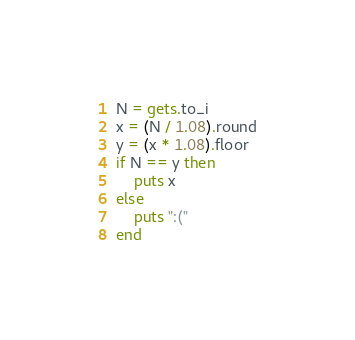<code> <loc_0><loc_0><loc_500><loc_500><_Ruby_>N = gets.to_i
x = (N / 1.08).round
y = (x * 1.08).floor
if N == y then
    puts x
else
    puts ":("
end</code> 